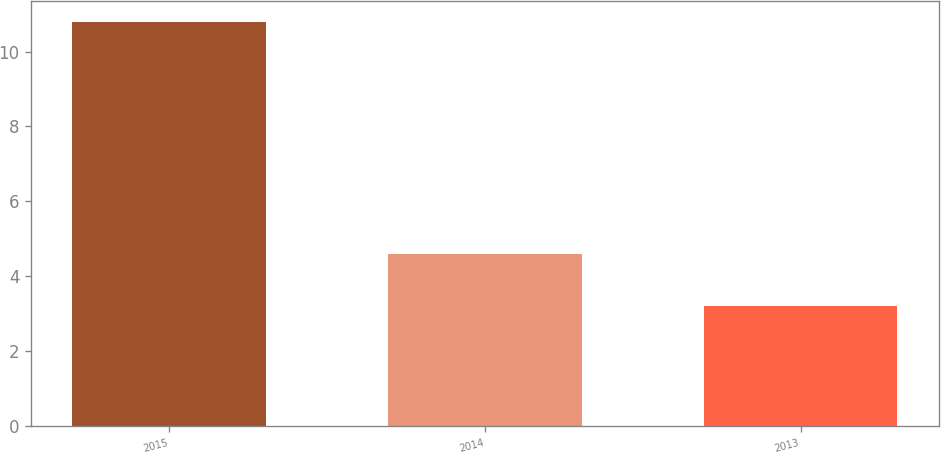Convert chart to OTSL. <chart><loc_0><loc_0><loc_500><loc_500><bar_chart><fcel>2015<fcel>2014<fcel>2013<nl><fcel>10.8<fcel>4.6<fcel>3.2<nl></chart> 